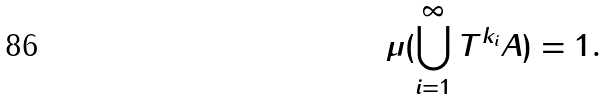Convert formula to latex. <formula><loc_0><loc_0><loc_500><loc_500>\mu ( \bigcup _ { i = 1 } ^ { \infty } T ^ { k _ { i } } A ) = 1 .</formula> 